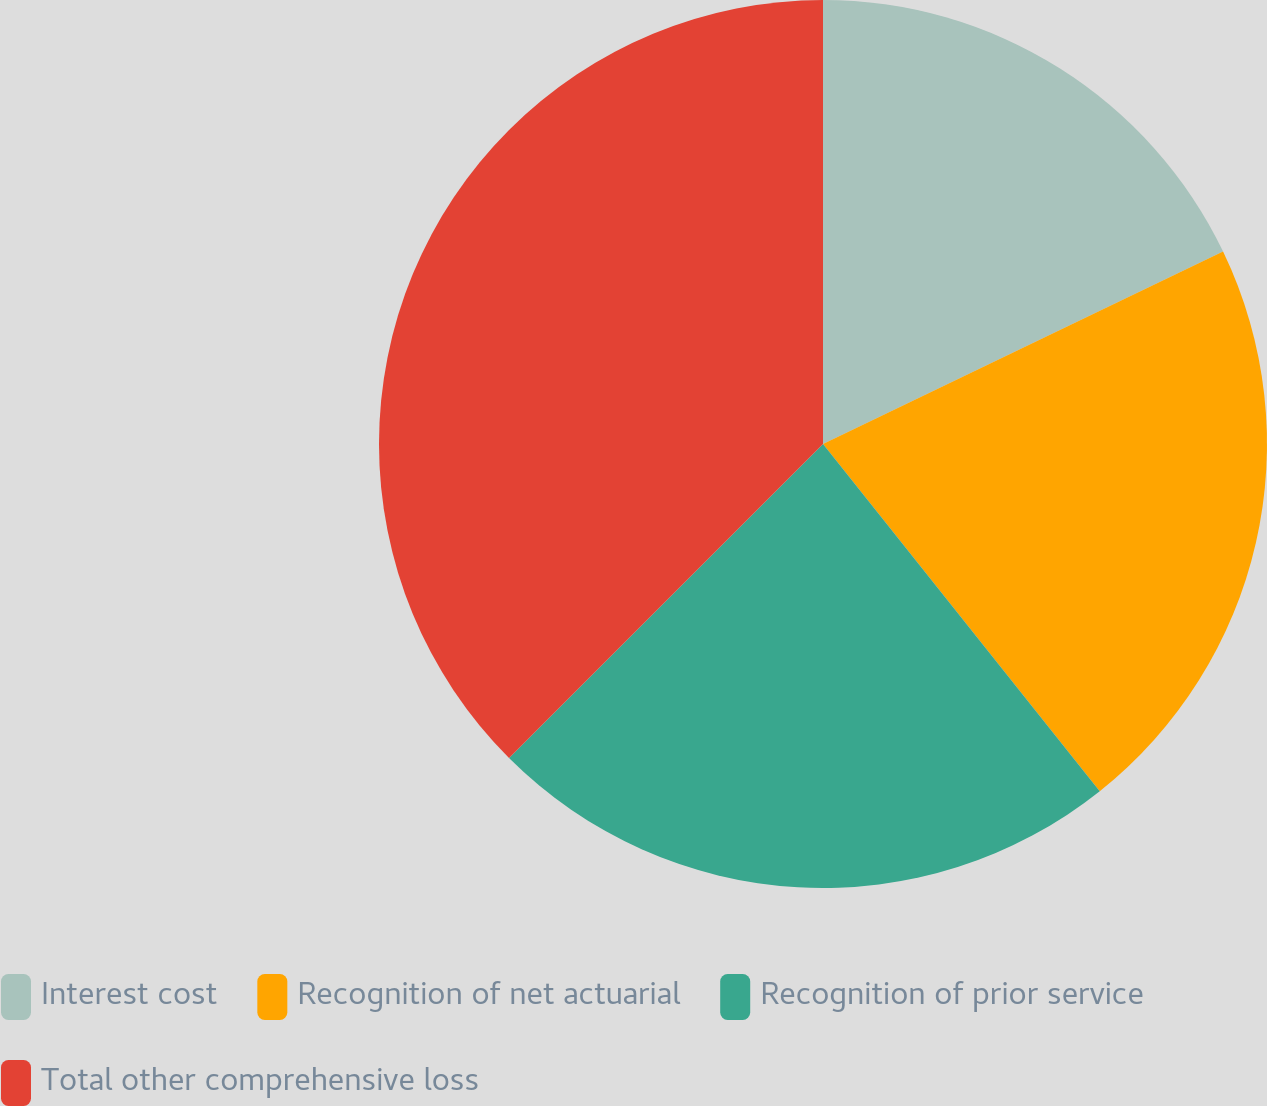<chart> <loc_0><loc_0><loc_500><loc_500><pie_chart><fcel>Interest cost<fcel>Recognition of net actuarial<fcel>Recognition of prior service<fcel>Total other comprehensive loss<nl><fcel>17.86%<fcel>21.43%<fcel>23.21%<fcel>37.5%<nl></chart> 